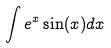<formula> <loc_0><loc_0><loc_500><loc_500>\int e ^ { x } \sin ( x ) d x</formula> 